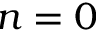Convert formula to latex. <formula><loc_0><loc_0><loc_500><loc_500>n = 0</formula> 